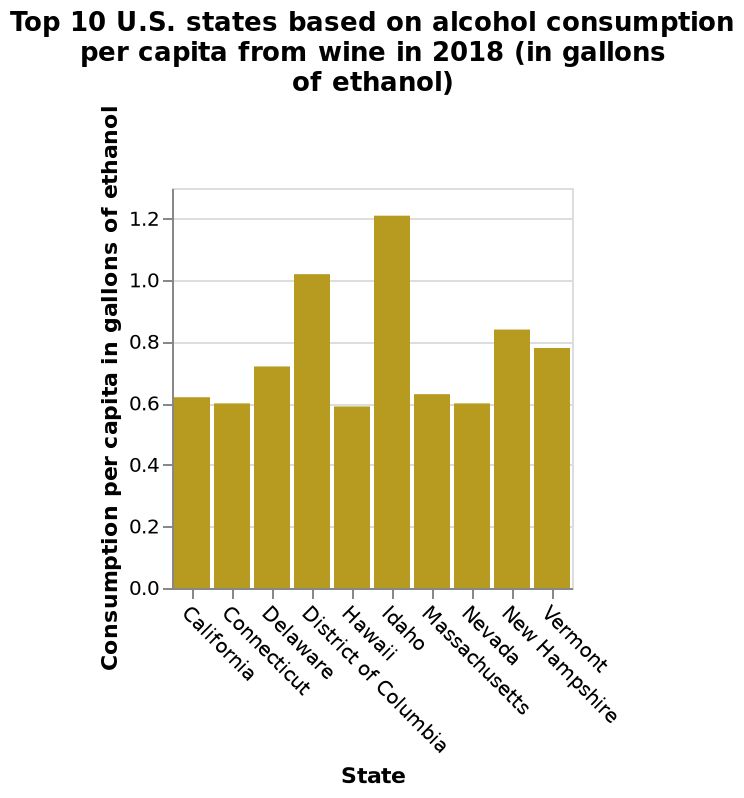<image>
Which state is represented by the bar furthest to the left on the x-axis?  The state represented by the bar furthest to the left on the x-axis is California. Which state is represented by the bar furthest to the right on the x-axis?  The state represented by the bar furthest to the right on the x-axis is Vermont. 